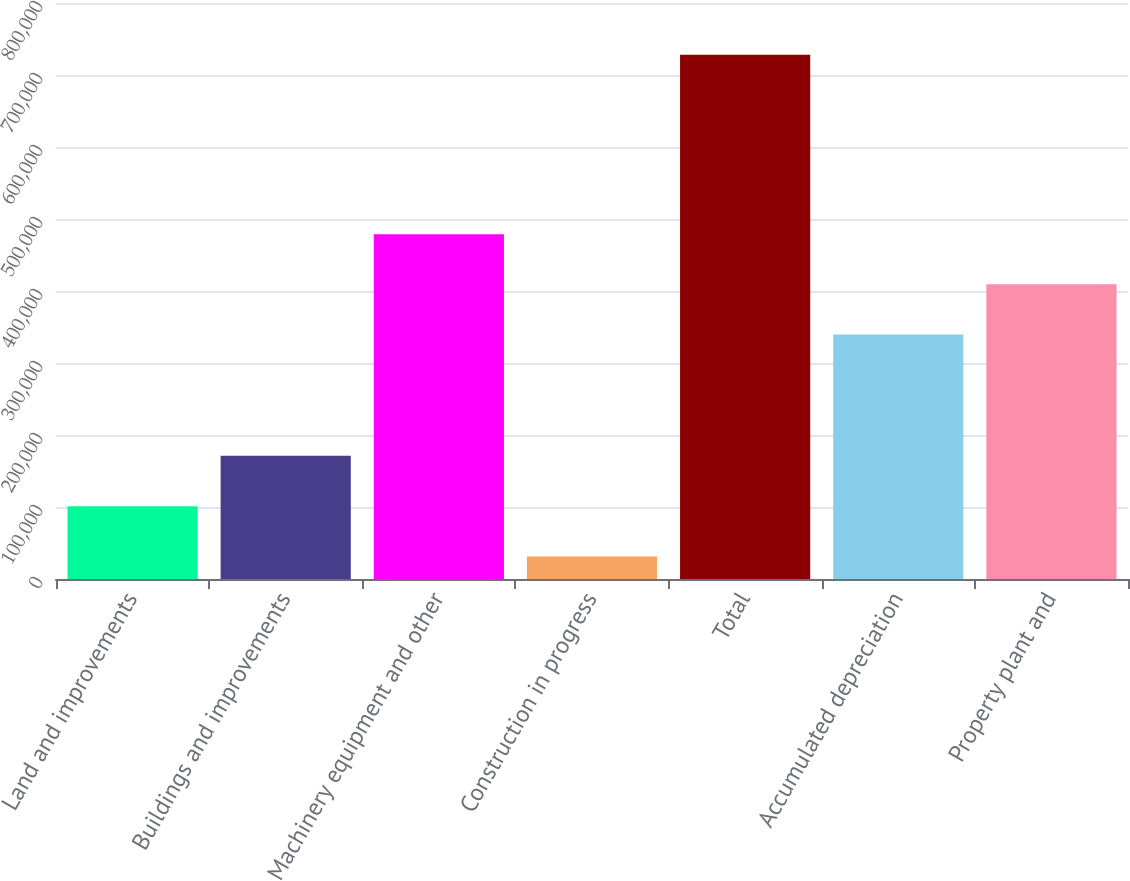Convert chart to OTSL. <chart><loc_0><loc_0><loc_500><loc_500><bar_chart><fcel>Land and improvements<fcel>Buildings and improvements<fcel>Machinery equipment and other<fcel>Construction in progress<fcel>Total<fcel>Accumulated depreciation<fcel>Property plant and<nl><fcel>100911<fcel>171269<fcel>478990<fcel>31237<fcel>727975<fcel>339642<fcel>409316<nl></chart> 